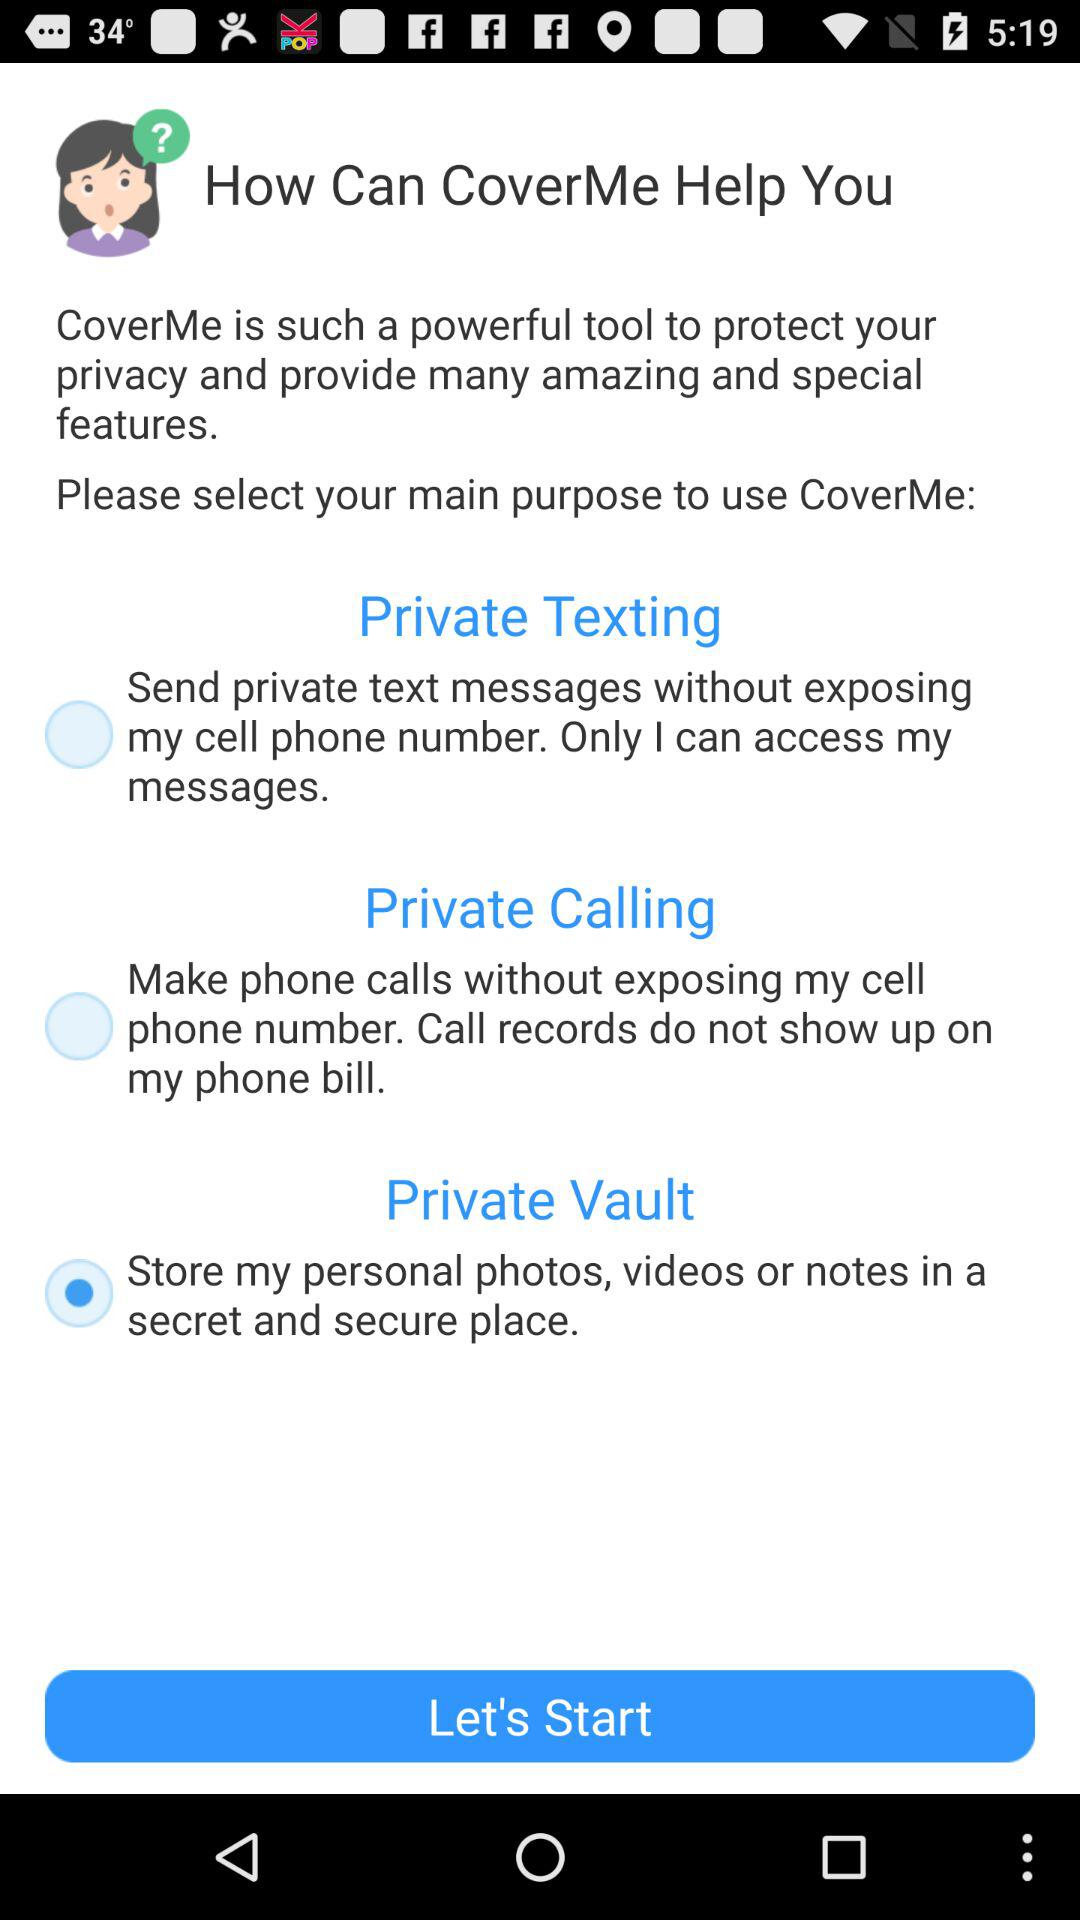What is the selected option? The selected option is to store my personal photos, videos or notes in a secret and secure place. 